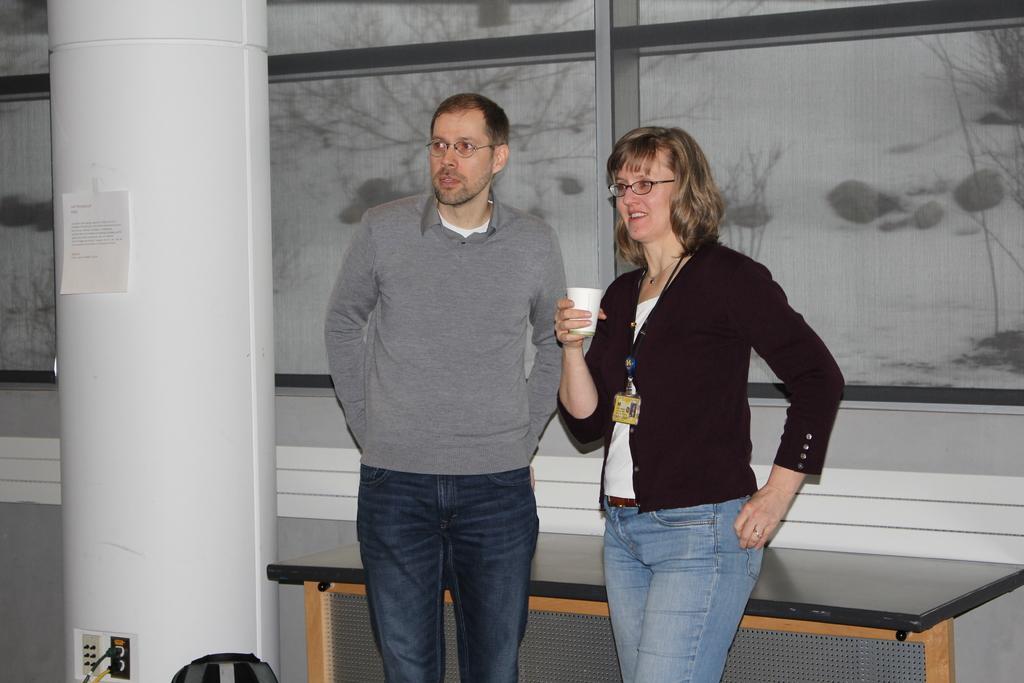Please provide a concise description of this image. In this image I can see one man and woman are standing and looking at the left side of the image. The man is wearing t-shirt and the woman is wearing black color jacket and holding a glass in her right hand. On the left side of the image there is a pillar. In the background I can see a wall. Just beside the person there is a bag. 